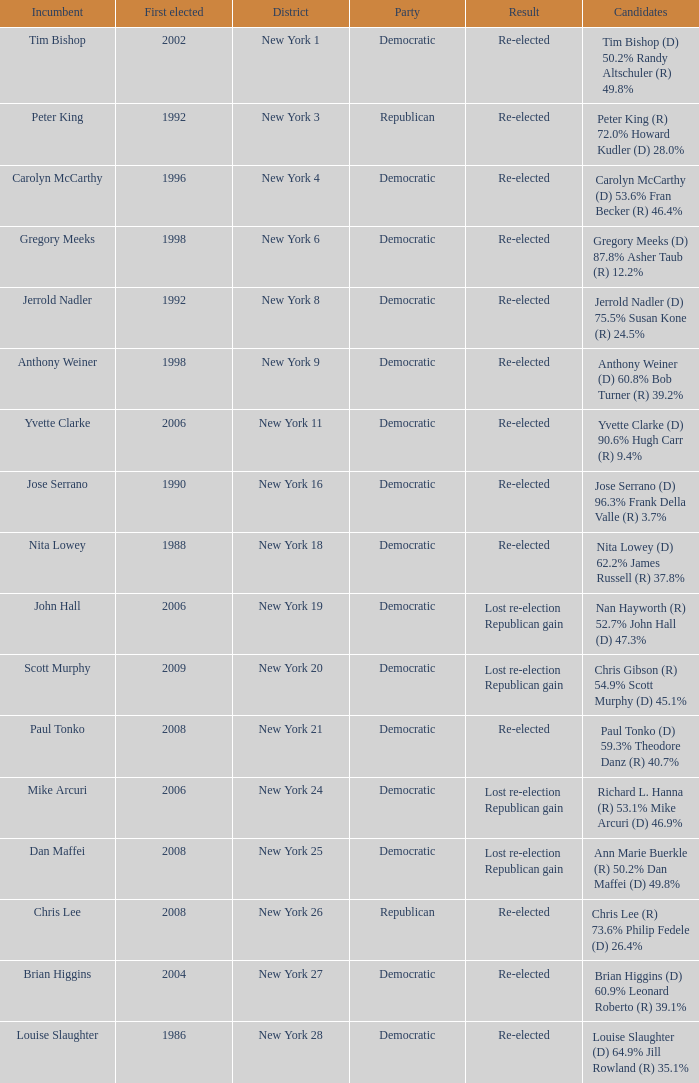Name the result for new york 8 Re-elected. 